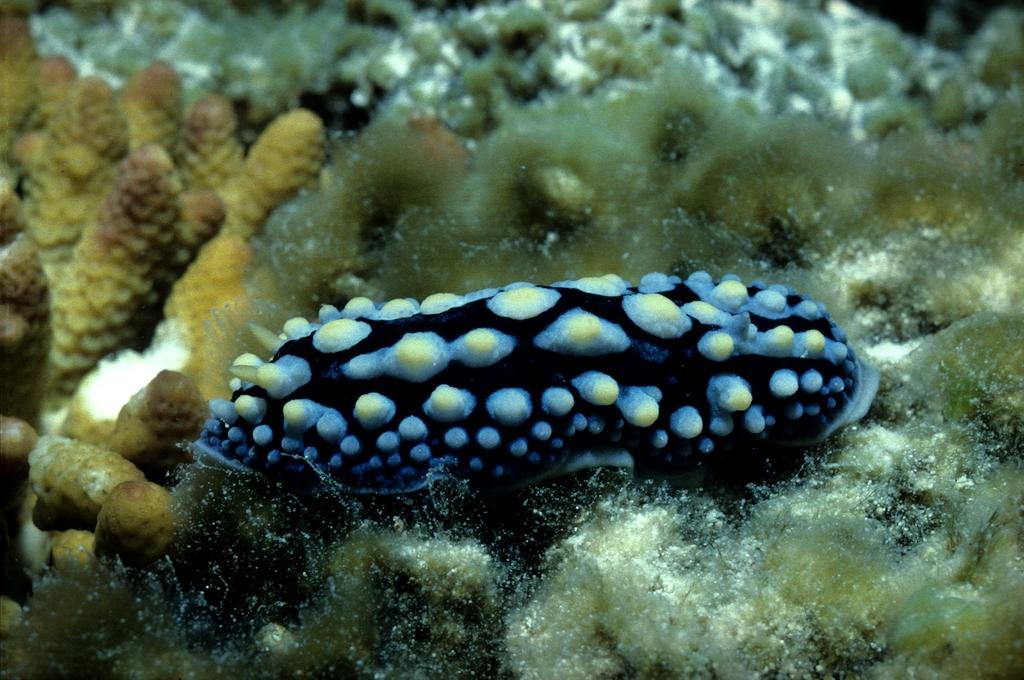What type of animal or organism can be seen in the image? There is a marine species in the image. What can be seen in the background of the image? There are marine plants in the background of the image. What is the tendency of the governor to visit the marine species in the image? There is no governor or indication of any visits in the image; it only features a marine species and marine plants. 